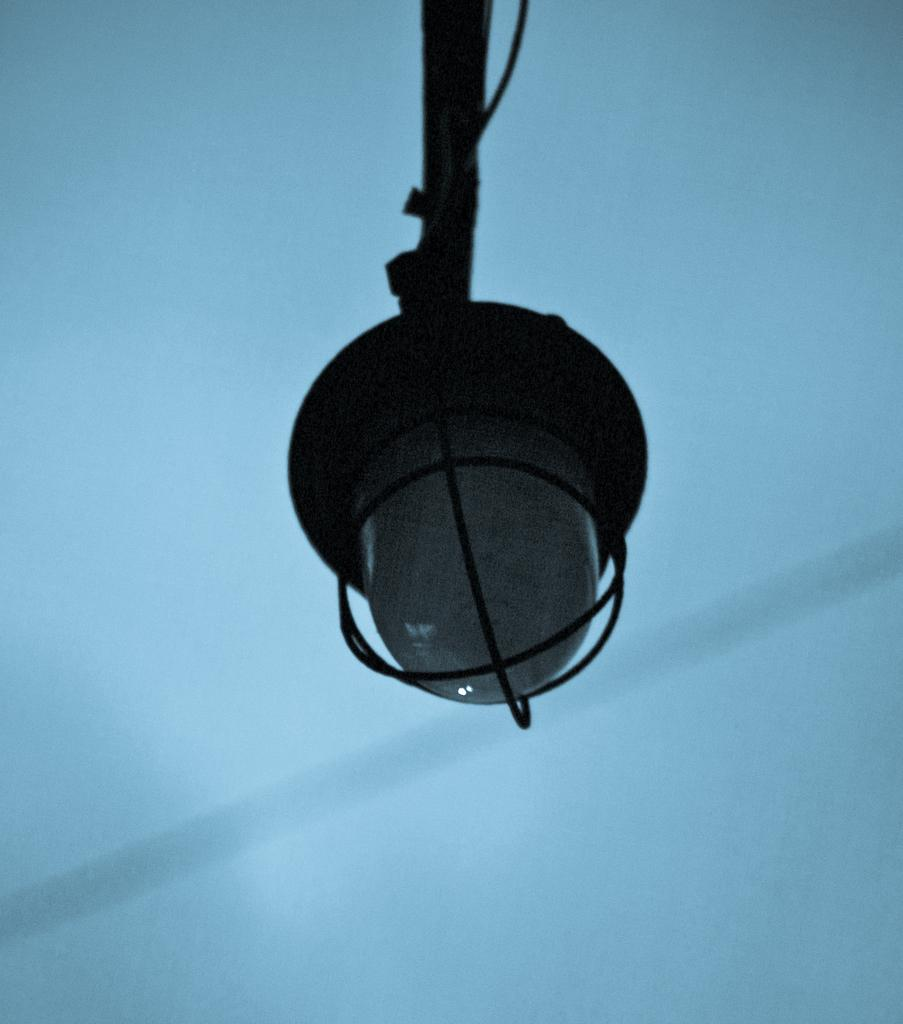What is hanging from the roof in the image? There is a light hanging from the roof in the image. What color is the background of the image? The background of the image is white. What type of soap is being used to clean the brass in the image? There is no soap, brass, or cleaning activity present in the image. 